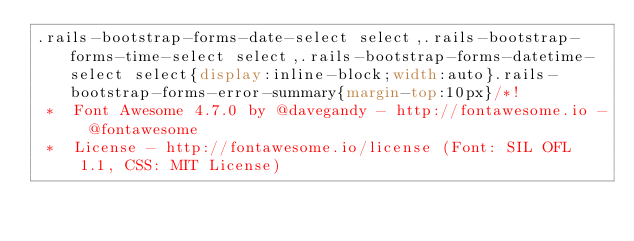<code> <loc_0><loc_0><loc_500><loc_500><_CSS_>.rails-bootstrap-forms-date-select select,.rails-bootstrap-forms-time-select select,.rails-bootstrap-forms-datetime-select select{display:inline-block;width:auto}.rails-bootstrap-forms-error-summary{margin-top:10px}/*!
 *  Font Awesome 4.7.0 by @davegandy - http://fontawesome.io - @fontawesome
 *  License - http://fontawesome.io/license (Font: SIL OFL 1.1, CSS: MIT License)</code> 